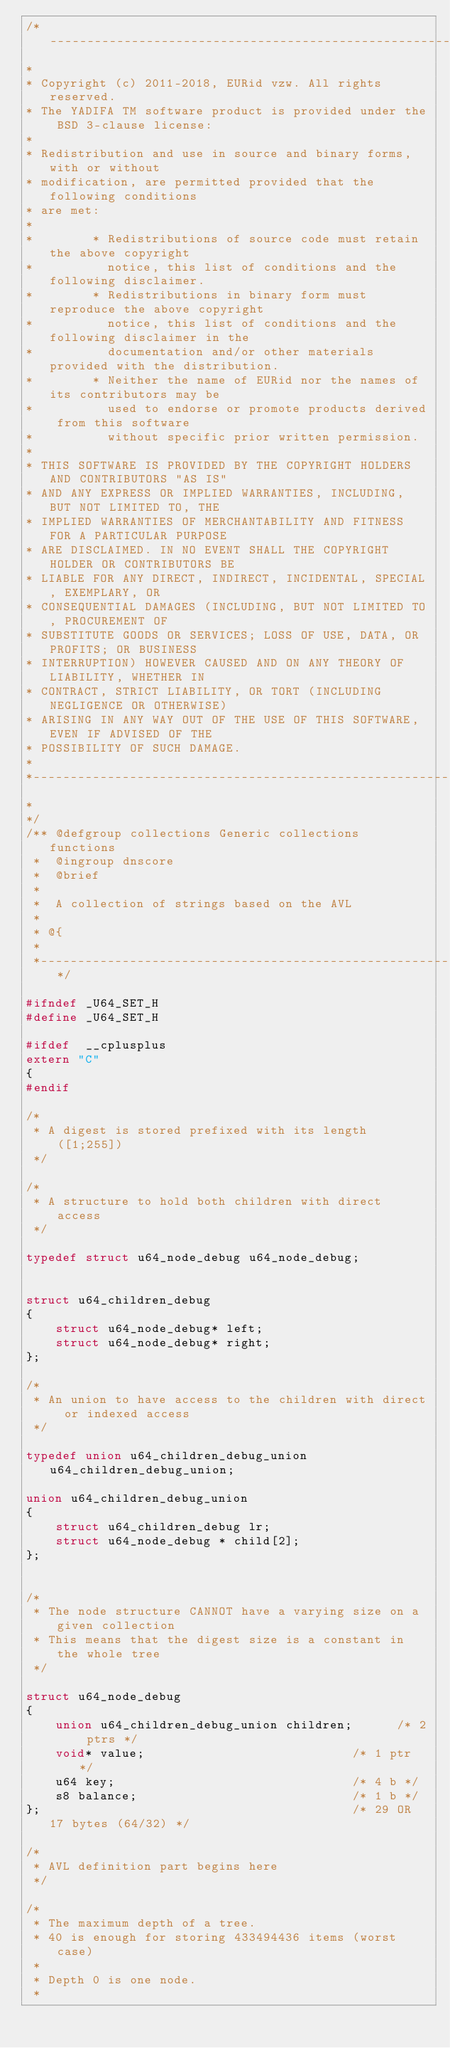<code> <loc_0><loc_0><loc_500><loc_500><_C_>/*------------------------------------------------------------------------------
*
* Copyright (c) 2011-2018, EURid vzw. All rights reserved.
* The YADIFA TM software product is provided under the BSD 3-clause license:
* 
* Redistribution and use in source and binary forms, with or without 
* modification, are permitted provided that the following conditions
* are met:
*
*        * Redistributions of source code must retain the above copyright 
*          notice, this list of conditions and the following disclaimer.
*        * Redistributions in binary form must reproduce the above copyright 
*          notice, this list of conditions and the following disclaimer in the 
*          documentation and/or other materials provided with the distribution.
*        * Neither the name of EURid nor the names of its contributors may be 
*          used to endorse or promote products derived from this software 
*          without specific prior written permission.
*
* THIS SOFTWARE IS PROVIDED BY THE COPYRIGHT HOLDERS AND CONTRIBUTORS "AS IS"
* AND ANY EXPRESS OR IMPLIED WARRANTIES, INCLUDING, BUT NOT LIMITED TO, THE 
* IMPLIED WARRANTIES OF MERCHANTABILITY AND FITNESS FOR A PARTICULAR PURPOSE 
* ARE DISCLAIMED. IN NO EVENT SHALL THE COPYRIGHT HOLDER OR CONTRIBUTORS BE
* LIABLE FOR ANY DIRECT, INDIRECT, INCIDENTAL, SPECIAL, EXEMPLARY, OR
* CONSEQUENTIAL DAMAGES (INCLUDING, BUT NOT LIMITED TO, PROCUREMENT OF 
* SUBSTITUTE GOODS OR SERVICES; LOSS OF USE, DATA, OR PROFITS; OR BUSINESS
* INTERRUPTION) HOWEVER CAUSED AND ON ANY THEORY OF LIABILITY, WHETHER IN 
* CONTRACT, STRICT LIABILITY, OR TORT (INCLUDING NEGLIGENCE OR OTHERWISE) 
* ARISING IN ANY WAY OUT OF THE USE OF THIS SOFTWARE, EVEN IF ADVISED OF THE
* POSSIBILITY OF SUCH DAMAGE.
*
*------------------------------------------------------------------------------
*
*/
/** @defgroup collections Generic collections functions
 *  @ingroup dnscore
 *  @brief 
 *
 *  A collection of strings based on the AVL
 *
 * @{
 *
 *----------------------------------------------------------------------------*/

#ifndef _U64_SET_H
#define	_U64_SET_H

#ifdef	__cplusplus
extern "C"
{
#endif

/*
 * A digest is stored prefixed with its length ([1;255])
 */

/*
 * A structure to hold both children with direct access
 */

typedef struct u64_node_debug u64_node_debug;


struct u64_children_debug
{
    struct u64_node_debug* left;
    struct u64_node_debug* right;
};

/*
 * An union to have access to the children with direct or indexed access
 */

typedef union u64_children_debug_union u64_children_debug_union;

union u64_children_debug_union
{
    struct u64_children_debug lr;
    struct u64_node_debug * child[2];
};


/*
 * The node structure CANNOT have a varying size on a given collection
 * This means that the digest size is a constant in the whole tree
 */

struct u64_node_debug
{
    union u64_children_debug_union children;      /* 2 ptrs */
    void* value;                            /* 1 ptr */
    u64 key;                                /* 4 b */
    s8 balance;                             /* 1 b */
};                                          /* 29 OR 17 bytes (64/32) */

/*
 * AVL definition part begins here
 */

/*
 * The maximum depth of a tree.
 * 40 is enough for storing 433494436 items (worst case)
 *
 * Depth 0 is one node.
 *</code> 